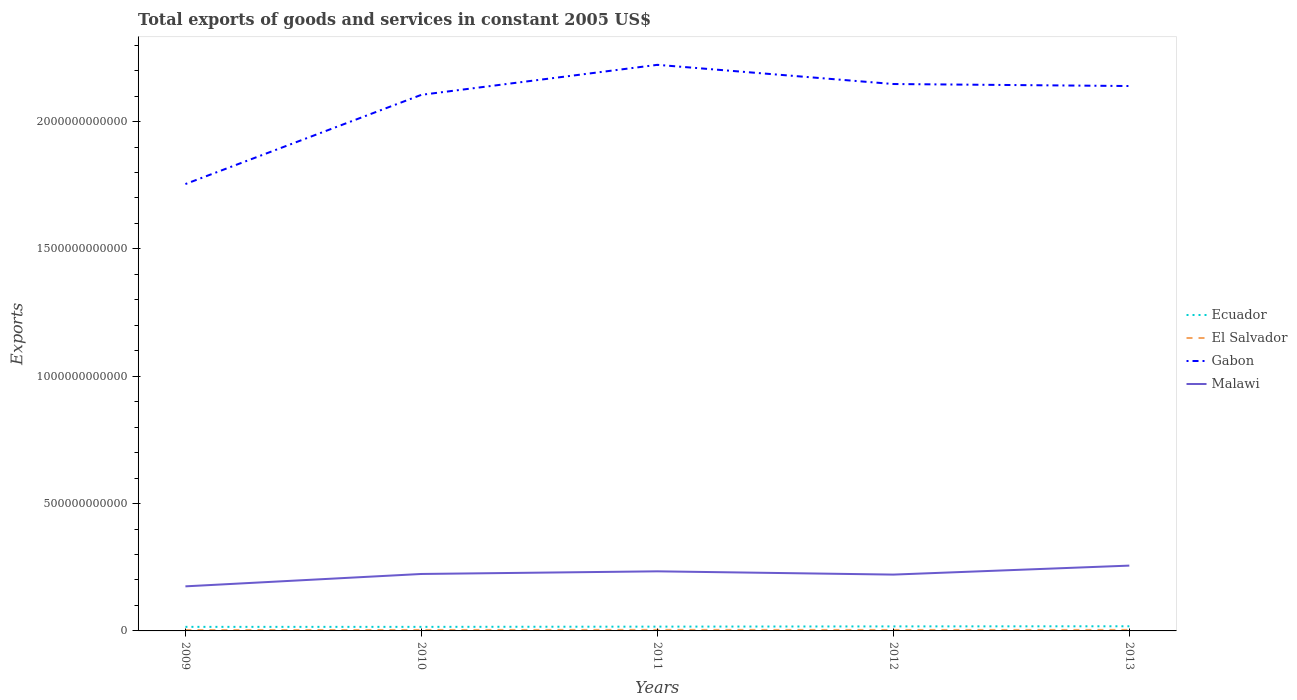Does the line corresponding to Malawi intersect with the line corresponding to El Salvador?
Offer a very short reply. No. Across all years, what is the maximum total exports of goods and services in Malawi?
Provide a short and direct response. 1.75e+11. In which year was the total exports of goods and services in Ecuador maximum?
Offer a terse response. 2010. What is the total total exports of goods and services in Ecuador in the graph?
Your answer should be compact. -2.29e+09. What is the difference between the highest and the second highest total exports of goods and services in Ecuador?
Make the answer very short. 2.29e+09. Is the total exports of goods and services in Malawi strictly greater than the total exports of goods and services in Ecuador over the years?
Your answer should be compact. No. How many lines are there?
Your answer should be very brief. 4. What is the difference between two consecutive major ticks on the Y-axis?
Make the answer very short. 5.00e+11. Are the values on the major ticks of Y-axis written in scientific E-notation?
Offer a terse response. No. Does the graph contain any zero values?
Keep it short and to the point. No. What is the title of the graph?
Provide a short and direct response. Total exports of goods and services in constant 2005 US$. Does "Other small states" appear as one of the legend labels in the graph?
Provide a succinct answer. No. What is the label or title of the X-axis?
Your response must be concise. Years. What is the label or title of the Y-axis?
Provide a succinct answer. Exports. What is the Exports in Ecuador in 2009?
Your answer should be very brief. 1.60e+1. What is the Exports in El Salvador in 2009?
Give a very brief answer. 3.36e+09. What is the Exports of Gabon in 2009?
Ensure brevity in your answer.  1.75e+12. What is the Exports of Malawi in 2009?
Provide a short and direct response. 1.75e+11. What is the Exports in Ecuador in 2010?
Your answer should be very brief. 1.59e+1. What is the Exports of El Salvador in 2010?
Keep it short and to the point. 3.75e+09. What is the Exports of Gabon in 2010?
Provide a short and direct response. 2.11e+12. What is the Exports in Malawi in 2010?
Your answer should be compact. 2.24e+11. What is the Exports of Ecuador in 2011?
Make the answer very short. 1.68e+1. What is the Exports of El Salvador in 2011?
Make the answer very short. 4.10e+09. What is the Exports in Gabon in 2011?
Give a very brief answer. 2.22e+12. What is the Exports of Malawi in 2011?
Make the answer very short. 2.34e+11. What is the Exports in Ecuador in 2012?
Your response must be concise. 1.78e+1. What is the Exports of El Salvador in 2012?
Give a very brief answer. 3.80e+09. What is the Exports of Gabon in 2012?
Give a very brief answer. 2.15e+12. What is the Exports of Malawi in 2012?
Your answer should be very brief. 2.21e+11. What is the Exports in Ecuador in 2013?
Keep it short and to the point. 1.82e+1. What is the Exports in El Salvador in 2013?
Give a very brief answer. 3.99e+09. What is the Exports of Gabon in 2013?
Your response must be concise. 2.14e+12. What is the Exports of Malawi in 2013?
Make the answer very short. 2.56e+11. Across all years, what is the maximum Exports in Ecuador?
Give a very brief answer. 1.82e+1. Across all years, what is the maximum Exports of El Salvador?
Keep it short and to the point. 4.10e+09. Across all years, what is the maximum Exports in Gabon?
Offer a very short reply. 2.22e+12. Across all years, what is the maximum Exports of Malawi?
Offer a very short reply. 2.56e+11. Across all years, what is the minimum Exports of Ecuador?
Your answer should be compact. 1.59e+1. Across all years, what is the minimum Exports of El Salvador?
Offer a very short reply. 3.36e+09. Across all years, what is the minimum Exports of Gabon?
Give a very brief answer. 1.75e+12. Across all years, what is the minimum Exports of Malawi?
Your answer should be very brief. 1.75e+11. What is the total Exports in Ecuador in the graph?
Your response must be concise. 8.47e+1. What is the total Exports in El Salvador in the graph?
Ensure brevity in your answer.  1.90e+1. What is the total Exports in Gabon in the graph?
Your answer should be compact. 1.04e+13. What is the total Exports of Malawi in the graph?
Your answer should be compact. 1.11e+12. What is the difference between the Exports in Ecuador in 2009 and that in 2010?
Provide a short and direct response. 3.79e+07. What is the difference between the Exports in El Salvador in 2009 and that in 2010?
Ensure brevity in your answer.  -3.91e+08. What is the difference between the Exports in Gabon in 2009 and that in 2010?
Ensure brevity in your answer.  -3.50e+11. What is the difference between the Exports in Malawi in 2009 and that in 2010?
Ensure brevity in your answer.  -4.86e+1. What is the difference between the Exports in Ecuador in 2009 and that in 2011?
Make the answer very short. -8.65e+08. What is the difference between the Exports of El Salvador in 2009 and that in 2011?
Your answer should be very brief. -7.39e+08. What is the difference between the Exports in Gabon in 2009 and that in 2011?
Make the answer very short. -4.68e+11. What is the difference between the Exports in Malawi in 2009 and that in 2011?
Your response must be concise. -5.90e+1. What is the difference between the Exports of Ecuador in 2009 and that in 2012?
Your answer should be very brief. -1.79e+09. What is the difference between the Exports in El Salvador in 2009 and that in 2012?
Keep it short and to the point. -4.38e+08. What is the difference between the Exports in Gabon in 2009 and that in 2012?
Your answer should be very brief. -3.93e+11. What is the difference between the Exports of Malawi in 2009 and that in 2012?
Ensure brevity in your answer.  -4.61e+1. What is the difference between the Exports of Ecuador in 2009 and that in 2013?
Provide a succinct answer. -2.26e+09. What is the difference between the Exports in El Salvador in 2009 and that in 2013?
Your answer should be very brief. -6.22e+08. What is the difference between the Exports of Gabon in 2009 and that in 2013?
Provide a succinct answer. -3.85e+11. What is the difference between the Exports in Malawi in 2009 and that in 2013?
Provide a short and direct response. -8.14e+1. What is the difference between the Exports of Ecuador in 2010 and that in 2011?
Offer a very short reply. -9.03e+08. What is the difference between the Exports in El Salvador in 2010 and that in 2011?
Provide a succinct answer. -3.48e+08. What is the difference between the Exports in Gabon in 2010 and that in 2011?
Ensure brevity in your answer.  -1.18e+11. What is the difference between the Exports in Malawi in 2010 and that in 2011?
Keep it short and to the point. -1.03e+1. What is the difference between the Exports in Ecuador in 2010 and that in 2012?
Your answer should be compact. -1.82e+09. What is the difference between the Exports of El Salvador in 2010 and that in 2012?
Your answer should be compact. -4.76e+07. What is the difference between the Exports of Gabon in 2010 and that in 2012?
Provide a short and direct response. -4.24e+1. What is the difference between the Exports in Malawi in 2010 and that in 2012?
Offer a very short reply. 2.50e+09. What is the difference between the Exports in Ecuador in 2010 and that in 2013?
Give a very brief answer. -2.29e+09. What is the difference between the Exports of El Salvador in 2010 and that in 2013?
Provide a short and direct response. -2.31e+08. What is the difference between the Exports of Gabon in 2010 and that in 2013?
Provide a short and direct response. -3.45e+1. What is the difference between the Exports in Malawi in 2010 and that in 2013?
Keep it short and to the point. -3.28e+1. What is the difference between the Exports of Ecuador in 2011 and that in 2012?
Offer a terse response. -9.20e+08. What is the difference between the Exports of El Salvador in 2011 and that in 2012?
Ensure brevity in your answer.  3.01e+08. What is the difference between the Exports of Gabon in 2011 and that in 2012?
Give a very brief answer. 7.53e+1. What is the difference between the Exports of Malawi in 2011 and that in 2012?
Keep it short and to the point. 1.28e+1. What is the difference between the Exports of Ecuador in 2011 and that in 2013?
Provide a short and direct response. -1.39e+09. What is the difference between the Exports of El Salvador in 2011 and that in 2013?
Make the answer very short. 1.17e+08. What is the difference between the Exports in Gabon in 2011 and that in 2013?
Provide a short and direct response. 8.32e+1. What is the difference between the Exports of Malawi in 2011 and that in 2013?
Offer a terse response. -2.24e+1. What is the difference between the Exports in Ecuador in 2012 and that in 2013?
Your answer should be compact. -4.70e+08. What is the difference between the Exports of El Salvador in 2012 and that in 2013?
Keep it short and to the point. -1.84e+08. What is the difference between the Exports in Gabon in 2012 and that in 2013?
Make the answer very short. 7.89e+09. What is the difference between the Exports in Malawi in 2012 and that in 2013?
Provide a succinct answer. -3.53e+1. What is the difference between the Exports in Ecuador in 2009 and the Exports in El Salvador in 2010?
Make the answer very short. 1.22e+1. What is the difference between the Exports in Ecuador in 2009 and the Exports in Gabon in 2010?
Give a very brief answer. -2.09e+12. What is the difference between the Exports of Ecuador in 2009 and the Exports of Malawi in 2010?
Ensure brevity in your answer.  -2.08e+11. What is the difference between the Exports of El Salvador in 2009 and the Exports of Gabon in 2010?
Provide a short and direct response. -2.10e+12. What is the difference between the Exports of El Salvador in 2009 and the Exports of Malawi in 2010?
Make the answer very short. -2.20e+11. What is the difference between the Exports of Gabon in 2009 and the Exports of Malawi in 2010?
Keep it short and to the point. 1.53e+12. What is the difference between the Exports of Ecuador in 2009 and the Exports of El Salvador in 2011?
Keep it short and to the point. 1.19e+1. What is the difference between the Exports in Ecuador in 2009 and the Exports in Gabon in 2011?
Your answer should be very brief. -2.21e+12. What is the difference between the Exports of Ecuador in 2009 and the Exports of Malawi in 2011?
Give a very brief answer. -2.18e+11. What is the difference between the Exports in El Salvador in 2009 and the Exports in Gabon in 2011?
Keep it short and to the point. -2.22e+12. What is the difference between the Exports of El Salvador in 2009 and the Exports of Malawi in 2011?
Your response must be concise. -2.31e+11. What is the difference between the Exports in Gabon in 2009 and the Exports in Malawi in 2011?
Keep it short and to the point. 1.52e+12. What is the difference between the Exports of Ecuador in 2009 and the Exports of El Salvador in 2012?
Offer a very short reply. 1.22e+1. What is the difference between the Exports in Ecuador in 2009 and the Exports in Gabon in 2012?
Ensure brevity in your answer.  -2.13e+12. What is the difference between the Exports of Ecuador in 2009 and the Exports of Malawi in 2012?
Provide a succinct answer. -2.05e+11. What is the difference between the Exports of El Salvador in 2009 and the Exports of Gabon in 2012?
Offer a terse response. -2.14e+12. What is the difference between the Exports of El Salvador in 2009 and the Exports of Malawi in 2012?
Ensure brevity in your answer.  -2.18e+11. What is the difference between the Exports in Gabon in 2009 and the Exports in Malawi in 2012?
Your answer should be compact. 1.53e+12. What is the difference between the Exports of Ecuador in 2009 and the Exports of El Salvador in 2013?
Make the answer very short. 1.20e+1. What is the difference between the Exports of Ecuador in 2009 and the Exports of Gabon in 2013?
Your answer should be compact. -2.12e+12. What is the difference between the Exports in Ecuador in 2009 and the Exports in Malawi in 2013?
Give a very brief answer. -2.40e+11. What is the difference between the Exports in El Salvador in 2009 and the Exports in Gabon in 2013?
Your answer should be compact. -2.14e+12. What is the difference between the Exports in El Salvador in 2009 and the Exports in Malawi in 2013?
Provide a succinct answer. -2.53e+11. What is the difference between the Exports in Gabon in 2009 and the Exports in Malawi in 2013?
Offer a very short reply. 1.50e+12. What is the difference between the Exports in Ecuador in 2010 and the Exports in El Salvador in 2011?
Provide a short and direct response. 1.18e+1. What is the difference between the Exports of Ecuador in 2010 and the Exports of Gabon in 2011?
Provide a succinct answer. -2.21e+12. What is the difference between the Exports of Ecuador in 2010 and the Exports of Malawi in 2011?
Your response must be concise. -2.18e+11. What is the difference between the Exports in El Salvador in 2010 and the Exports in Gabon in 2011?
Provide a short and direct response. -2.22e+12. What is the difference between the Exports of El Salvador in 2010 and the Exports of Malawi in 2011?
Offer a very short reply. -2.30e+11. What is the difference between the Exports in Gabon in 2010 and the Exports in Malawi in 2011?
Make the answer very short. 1.87e+12. What is the difference between the Exports in Ecuador in 2010 and the Exports in El Salvador in 2012?
Provide a short and direct response. 1.21e+1. What is the difference between the Exports of Ecuador in 2010 and the Exports of Gabon in 2012?
Provide a succinct answer. -2.13e+12. What is the difference between the Exports in Ecuador in 2010 and the Exports in Malawi in 2012?
Provide a short and direct response. -2.05e+11. What is the difference between the Exports in El Salvador in 2010 and the Exports in Gabon in 2012?
Provide a succinct answer. -2.14e+12. What is the difference between the Exports in El Salvador in 2010 and the Exports in Malawi in 2012?
Provide a short and direct response. -2.17e+11. What is the difference between the Exports of Gabon in 2010 and the Exports of Malawi in 2012?
Ensure brevity in your answer.  1.88e+12. What is the difference between the Exports in Ecuador in 2010 and the Exports in El Salvador in 2013?
Make the answer very short. 1.19e+1. What is the difference between the Exports in Ecuador in 2010 and the Exports in Gabon in 2013?
Provide a short and direct response. -2.12e+12. What is the difference between the Exports in Ecuador in 2010 and the Exports in Malawi in 2013?
Your answer should be very brief. -2.41e+11. What is the difference between the Exports of El Salvador in 2010 and the Exports of Gabon in 2013?
Keep it short and to the point. -2.14e+12. What is the difference between the Exports in El Salvador in 2010 and the Exports in Malawi in 2013?
Your answer should be compact. -2.53e+11. What is the difference between the Exports in Gabon in 2010 and the Exports in Malawi in 2013?
Ensure brevity in your answer.  1.85e+12. What is the difference between the Exports in Ecuador in 2011 and the Exports in El Salvador in 2012?
Your answer should be compact. 1.30e+1. What is the difference between the Exports in Ecuador in 2011 and the Exports in Gabon in 2012?
Your answer should be compact. -2.13e+12. What is the difference between the Exports in Ecuador in 2011 and the Exports in Malawi in 2012?
Ensure brevity in your answer.  -2.04e+11. What is the difference between the Exports of El Salvador in 2011 and the Exports of Gabon in 2012?
Your response must be concise. -2.14e+12. What is the difference between the Exports in El Salvador in 2011 and the Exports in Malawi in 2012?
Provide a succinct answer. -2.17e+11. What is the difference between the Exports in Gabon in 2011 and the Exports in Malawi in 2012?
Your answer should be compact. 2.00e+12. What is the difference between the Exports of Ecuador in 2011 and the Exports of El Salvador in 2013?
Ensure brevity in your answer.  1.29e+1. What is the difference between the Exports of Ecuador in 2011 and the Exports of Gabon in 2013?
Ensure brevity in your answer.  -2.12e+12. What is the difference between the Exports of Ecuador in 2011 and the Exports of Malawi in 2013?
Ensure brevity in your answer.  -2.40e+11. What is the difference between the Exports of El Salvador in 2011 and the Exports of Gabon in 2013?
Offer a terse response. -2.14e+12. What is the difference between the Exports of El Salvador in 2011 and the Exports of Malawi in 2013?
Offer a very short reply. -2.52e+11. What is the difference between the Exports in Gabon in 2011 and the Exports in Malawi in 2013?
Provide a succinct answer. 1.97e+12. What is the difference between the Exports of Ecuador in 2012 and the Exports of El Salvador in 2013?
Offer a terse response. 1.38e+1. What is the difference between the Exports of Ecuador in 2012 and the Exports of Gabon in 2013?
Offer a very short reply. -2.12e+12. What is the difference between the Exports of Ecuador in 2012 and the Exports of Malawi in 2013?
Provide a succinct answer. -2.39e+11. What is the difference between the Exports of El Salvador in 2012 and the Exports of Gabon in 2013?
Offer a very short reply. -2.14e+12. What is the difference between the Exports of El Salvador in 2012 and the Exports of Malawi in 2013?
Keep it short and to the point. -2.53e+11. What is the difference between the Exports in Gabon in 2012 and the Exports in Malawi in 2013?
Your answer should be compact. 1.89e+12. What is the average Exports of Ecuador per year?
Make the answer very short. 1.69e+1. What is the average Exports of El Salvador per year?
Offer a very short reply. 3.80e+09. What is the average Exports of Gabon per year?
Provide a succinct answer. 2.07e+12. What is the average Exports of Malawi per year?
Make the answer very short. 2.22e+11. In the year 2009, what is the difference between the Exports in Ecuador and Exports in El Salvador?
Offer a terse response. 1.26e+1. In the year 2009, what is the difference between the Exports of Ecuador and Exports of Gabon?
Offer a terse response. -1.74e+12. In the year 2009, what is the difference between the Exports in Ecuador and Exports in Malawi?
Your answer should be very brief. -1.59e+11. In the year 2009, what is the difference between the Exports in El Salvador and Exports in Gabon?
Ensure brevity in your answer.  -1.75e+12. In the year 2009, what is the difference between the Exports of El Salvador and Exports of Malawi?
Ensure brevity in your answer.  -1.72e+11. In the year 2009, what is the difference between the Exports of Gabon and Exports of Malawi?
Provide a short and direct response. 1.58e+12. In the year 2010, what is the difference between the Exports of Ecuador and Exports of El Salvador?
Give a very brief answer. 1.22e+1. In the year 2010, what is the difference between the Exports of Ecuador and Exports of Gabon?
Give a very brief answer. -2.09e+12. In the year 2010, what is the difference between the Exports in Ecuador and Exports in Malawi?
Offer a terse response. -2.08e+11. In the year 2010, what is the difference between the Exports in El Salvador and Exports in Gabon?
Keep it short and to the point. -2.10e+12. In the year 2010, what is the difference between the Exports in El Salvador and Exports in Malawi?
Provide a short and direct response. -2.20e+11. In the year 2010, what is the difference between the Exports of Gabon and Exports of Malawi?
Your response must be concise. 1.88e+12. In the year 2011, what is the difference between the Exports in Ecuador and Exports in El Salvador?
Your answer should be very brief. 1.27e+1. In the year 2011, what is the difference between the Exports of Ecuador and Exports of Gabon?
Give a very brief answer. -2.21e+12. In the year 2011, what is the difference between the Exports of Ecuador and Exports of Malawi?
Make the answer very short. -2.17e+11. In the year 2011, what is the difference between the Exports in El Salvador and Exports in Gabon?
Make the answer very short. -2.22e+12. In the year 2011, what is the difference between the Exports of El Salvador and Exports of Malawi?
Keep it short and to the point. -2.30e+11. In the year 2011, what is the difference between the Exports of Gabon and Exports of Malawi?
Offer a very short reply. 1.99e+12. In the year 2012, what is the difference between the Exports of Ecuador and Exports of El Salvador?
Your response must be concise. 1.40e+1. In the year 2012, what is the difference between the Exports of Ecuador and Exports of Gabon?
Provide a succinct answer. -2.13e+12. In the year 2012, what is the difference between the Exports in Ecuador and Exports in Malawi?
Your answer should be very brief. -2.03e+11. In the year 2012, what is the difference between the Exports in El Salvador and Exports in Gabon?
Give a very brief answer. -2.14e+12. In the year 2012, what is the difference between the Exports of El Salvador and Exports of Malawi?
Make the answer very short. -2.17e+11. In the year 2012, what is the difference between the Exports in Gabon and Exports in Malawi?
Your answer should be compact. 1.93e+12. In the year 2013, what is the difference between the Exports of Ecuador and Exports of El Salvador?
Make the answer very short. 1.42e+1. In the year 2013, what is the difference between the Exports in Ecuador and Exports in Gabon?
Make the answer very short. -2.12e+12. In the year 2013, what is the difference between the Exports in Ecuador and Exports in Malawi?
Your answer should be very brief. -2.38e+11. In the year 2013, what is the difference between the Exports of El Salvador and Exports of Gabon?
Provide a succinct answer. -2.14e+12. In the year 2013, what is the difference between the Exports of El Salvador and Exports of Malawi?
Offer a terse response. -2.52e+11. In the year 2013, what is the difference between the Exports of Gabon and Exports of Malawi?
Provide a short and direct response. 1.88e+12. What is the ratio of the Exports in Ecuador in 2009 to that in 2010?
Your answer should be compact. 1. What is the ratio of the Exports of El Salvador in 2009 to that in 2010?
Offer a very short reply. 0.9. What is the ratio of the Exports in Gabon in 2009 to that in 2010?
Offer a terse response. 0.83. What is the ratio of the Exports in Malawi in 2009 to that in 2010?
Provide a succinct answer. 0.78. What is the ratio of the Exports in Ecuador in 2009 to that in 2011?
Offer a terse response. 0.95. What is the ratio of the Exports of El Salvador in 2009 to that in 2011?
Offer a terse response. 0.82. What is the ratio of the Exports in Gabon in 2009 to that in 2011?
Give a very brief answer. 0.79. What is the ratio of the Exports of Malawi in 2009 to that in 2011?
Provide a short and direct response. 0.75. What is the ratio of the Exports in Ecuador in 2009 to that in 2012?
Provide a short and direct response. 0.9. What is the ratio of the Exports of El Salvador in 2009 to that in 2012?
Give a very brief answer. 0.88. What is the ratio of the Exports in Gabon in 2009 to that in 2012?
Give a very brief answer. 0.82. What is the ratio of the Exports of Malawi in 2009 to that in 2012?
Offer a terse response. 0.79. What is the ratio of the Exports of Ecuador in 2009 to that in 2013?
Provide a succinct answer. 0.88. What is the ratio of the Exports in El Salvador in 2009 to that in 2013?
Give a very brief answer. 0.84. What is the ratio of the Exports of Gabon in 2009 to that in 2013?
Keep it short and to the point. 0.82. What is the ratio of the Exports of Malawi in 2009 to that in 2013?
Provide a short and direct response. 0.68. What is the ratio of the Exports in Ecuador in 2010 to that in 2011?
Your answer should be compact. 0.95. What is the ratio of the Exports in El Salvador in 2010 to that in 2011?
Provide a short and direct response. 0.92. What is the ratio of the Exports of Gabon in 2010 to that in 2011?
Make the answer very short. 0.95. What is the ratio of the Exports of Malawi in 2010 to that in 2011?
Give a very brief answer. 0.96. What is the ratio of the Exports of Ecuador in 2010 to that in 2012?
Your answer should be compact. 0.9. What is the ratio of the Exports of El Salvador in 2010 to that in 2012?
Your answer should be very brief. 0.99. What is the ratio of the Exports of Gabon in 2010 to that in 2012?
Keep it short and to the point. 0.98. What is the ratio of the Exports in Malawi in 2010 to that in 2012?
Offer a terse response. 1.01. What is the ratio of the Exports of Ecuador in 2010 to that in 2013?
Give a very brief answer. 0.87. What is the ratio of the Exports of El Salvador in 2010 to that in 2013?
Provide a succinct answer. 0.94. What is the ratio of the Exports of Gabon in 2010 to that in 2013?
Offer a terse response. 0.98. What is the ratio of the Exports of Malawi in 2010 to that in 2013?
Keep it short and to the point. 0.87. What is the ratio of the Exports in Ecuador in 2011 to that in 2012?
Ensure brevity in your answer.  0.95. What is the ratio of the Exports of El Salvador in 2011 to that in 2012?
Your answer should be very brief. 1.08. What is the ratio of the Exports of Gabon in 2011 to that in 2012?
Your response must be concise. 1.04. What is the ratio of the Exports of Malawi in 2011 to that in 2012?
Your answer should be compact. 1.06. What is the ratio of the Exports of Ecuador in 2011 to that in 2013?
Give a very brief answer. 0.92. What is the ratio of the Exports in El Salvador in 2011 to that in 2013?
Provide a short and direct response. 1.03. What is the ratio of the Exports in Gabon in 2011 to that in 2013?
Ensure brevity in your answer.  1.04. What is the ratio of the Exports in Malawi in 2011 to that in 2013?
Offer a very short reply. 0.91. What is the ratio of the Exports in Ecuador in 2012 to that in 2013?
Keep it short and to the point. 0.97. What is the ratio of the Exports in El Salvador in 2012 to that in 2013?
Offer a terse response. 0.95. What is the ratio of the Exports in Malawi in 2012 to that in 2013?
Your response must be concise. 0.86. What is the difference between the highest and the second highest Exports in Ecuador?
Keep it short and to the point. 4.70e+08. What is the difference between the highest and the second highest Exports of El Salvador?
Give a very brief answer. 1.17e+08. What is the difference between the highest and the second highest Exports of Gabon?
Provide a short and direct response. 7.53e+1. What is the difference between the highest and the second highest Exports in Malawi?
Your answer should be compact. 2.24e+1. What is the difference between the highest and the lowest Exports of Ecuador?
Your answer should be very brief. 2.29e+09. What is the difference between the highest and the lowest Exports of El Salvador?
Make the answer very short. 7.39e+08. What is the difference between the highest and the lowest Exports of Gabon?
Your answer should be very brief. 4.68e+11. What is the difference between the highest and the lowest Exports of Malawi?
Ensure brevity in your answer.  8.14e+1. 